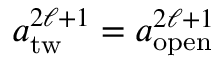<formula> <loc_0><loc_0><loc_500><loc_500>\begin{array} { r l r } { { a _ { t w } ^ { 2 \ell + 1 } = a _ { o p e n } ^ { 2 \ell + 1 } } } \end{array}</formula> 